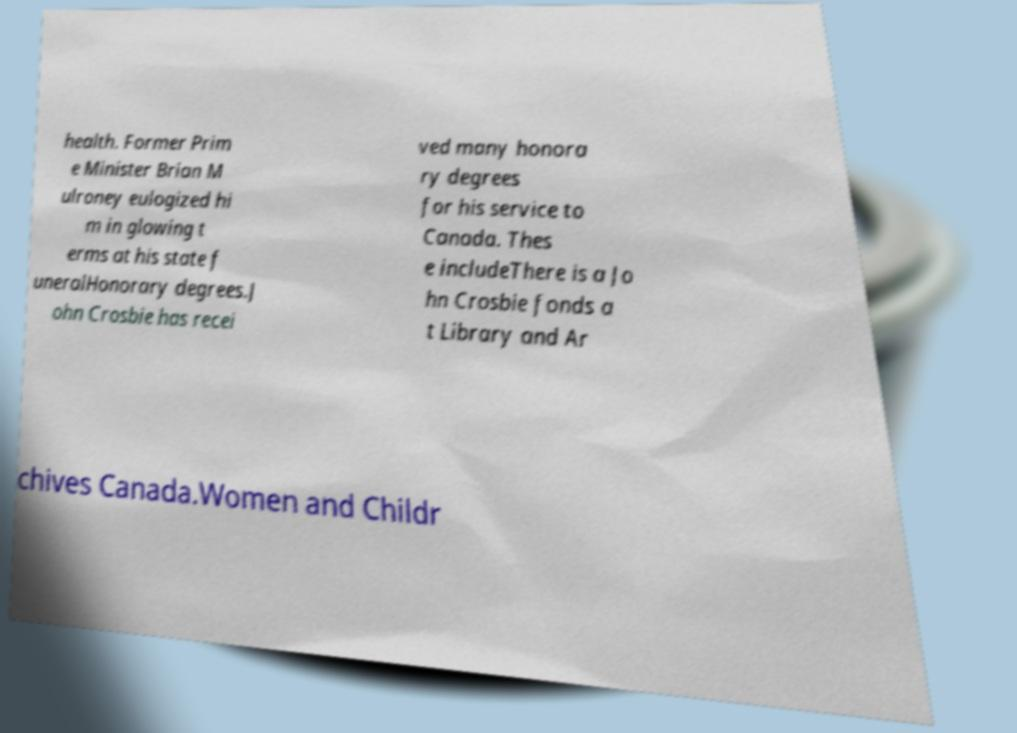Can you read and provide the text displayed in the image?This photo seems to have some interesting text. Can you extract and type it out for me? health. Former Prim e Minister Brian M ulroney eulogized hi m in glowing t erms at his state f uneralHonorary degrees.J ohn Crosbie has recei ved many honora ry degrees for his service to Canada. Thes e includeThere is a Jo hn Crosbie fonds a t Library and Ar chives Canada.Women and Childr 